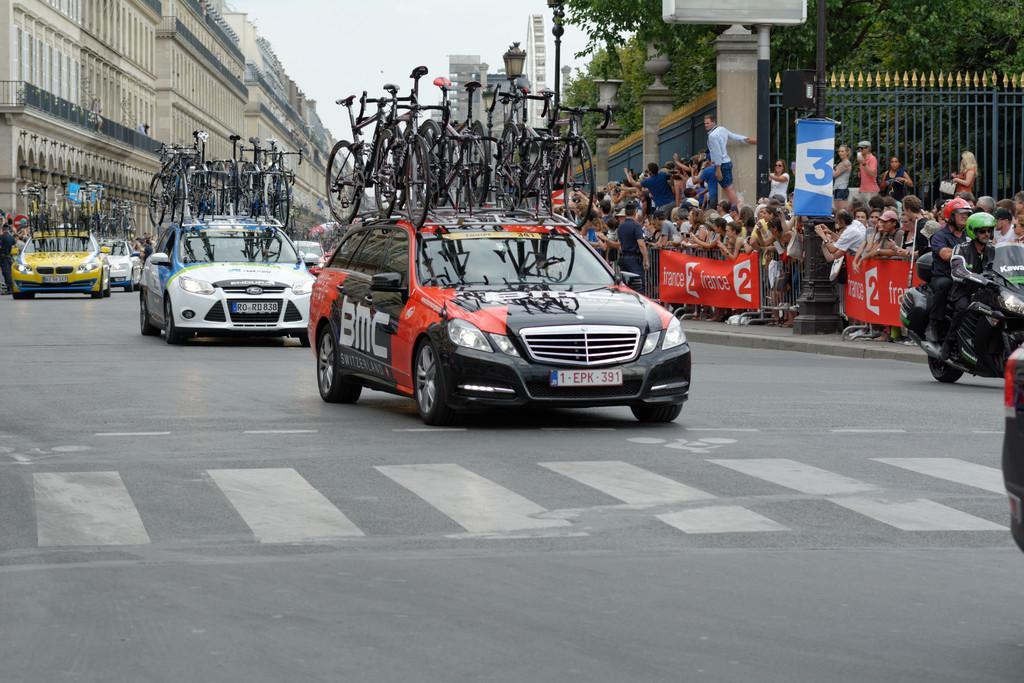How would you summarize this image in a sentence or two? In this picture I can see few buildings and few cars on the road, carrying bicycles on the roof of the cars and few people standing on both sides of the road and I see a motorcycle and couple of them seated on it and they wore helmets and few banners with some text and trees and a metal fence and a cloudy Sky and few pole lights. 